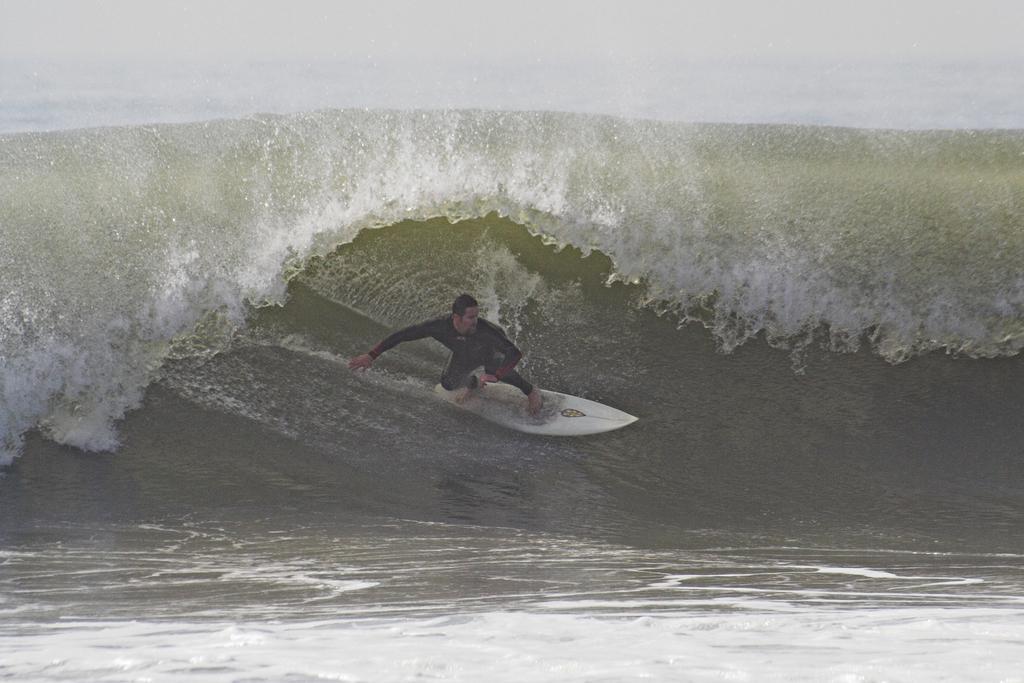In one or two sentences, can you explain what this image depicts? This picture is clicked outside the city. In the center there is a person surfing on a surfboard. In the background we can see the ripples in the water body. 